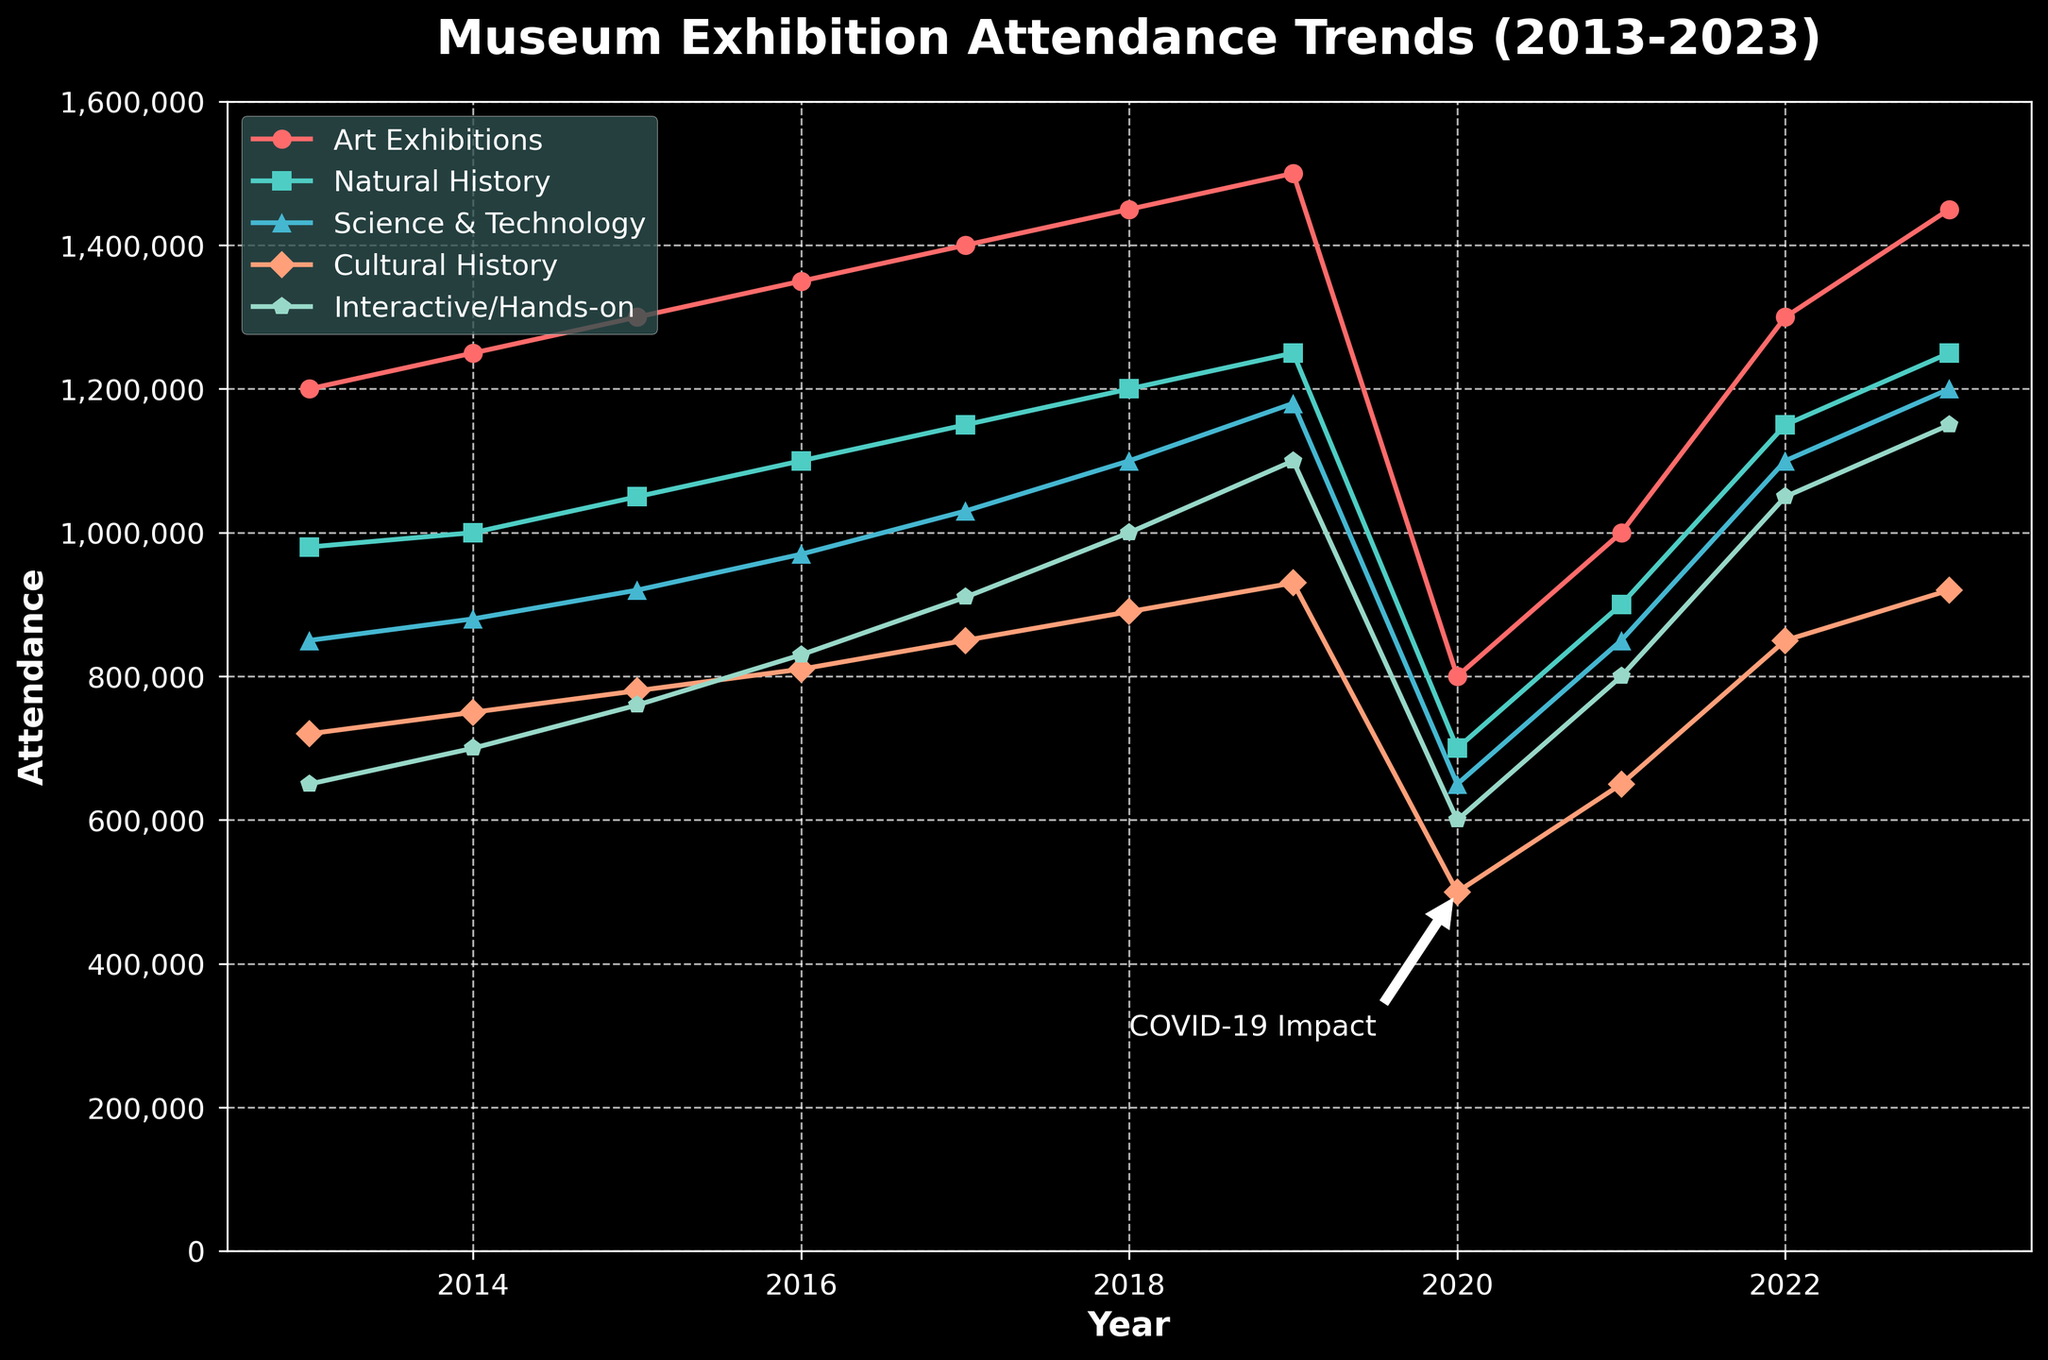Which exhibition had the highest attendance in 2023? Look at the 2023 attendance values for all exhibitions and identify the highest value.
Answer: Art Exhibitions How did the attendance of Science & Technology exhibitions change from 2019 to 2020? Compare the Science & Technology attendance in 2019 (1,180,000) and 2020 (650,000). Calculate the difference: 1,180,000 - 650,000 = 530,000.
Answer: Decreased by 530,000 Which types of exhibitions showed a decline in attendance between 2019 and 2020? Compare the attendance values for all exhibitions for the years 2019 and 2020. Art Exhibitions (1,500,000 to 800,000), Natural History (1,250,000 to 700,000), Science & Technology (1,180,000 to 650,000), Cultural History (930,000 to 500,000), and Interactive/Hands-on (1,100,000 to 600,000) all declined.
Answer: All types By what percentage did the attendance for Interactive/Hands-on exhibitions increase from 2020 to 2021? Calculate the percentage change from 2020 (600,000) to 2021 (800,000). The formula is ((new value - old value) / old value) * 100. ((800,000 - 600,000) / 600,000) * 100 = 33.3%.
Answer: 33.3% Which type of exhibition had the most stable (least variable) attendance over the decade? Evaluate the consistency in attendance values for each exhibition type by visual inspection. Art Exhibitions showed a steady increase in attendance every year with a significant drop in 2020 due to COVID-19 but recovered quickly, indicating overall stability.
Answer: Art Exhibitions Did any exhibition type recover to pre-2020 levels by 2023? Compare the 2023 attendance values to those of 2019 (pre-2020) for each exhibition. Both Art Exhibitions (1,450,000 in 2023 vs 1,500,000 in 2019) and Interactive/Hands-on (1,150,000 in 2023 vs 1,100,000 in 2019) closely match their pre-2020 levels.
Answer: Yes, Art Exhibitions and Interactive/Hands-on What is the average attendance for Cultural History exhibitions from 2013 to 2023? Sum the Cultural History attendance values from 2013 to 2023 and divide by the number of years: (720,000 + 750,000 + 780,000 + 810,000 + 850,000 + 890,000 + 930,000 + 500,000 + 650,000 + 850,000 + 920,000) / 11. Total sum is 8,650,000. Average = 8,650,000 / 11 = 786,364 (rounded).
Answer: 786,364 What trend can be observed in the attendance for Natural History exhibitions from 2013 to 2019? Examine the attendance values for Natural History from 2013 (980,000) to 2019 (1,250,000). The values show a steady increase each year.
Answer: Increasing trend How does the attendance for Interactive/Hands-on exhibitions in 2016 compare to that in 2013? Compare the attendance values for Interactive/Hands-on exhibitions in 2016 (830,000) and 2013 (650,000). 830,000 - 650,000 = 180,000 increase.
Answer: Increased by 180,000 